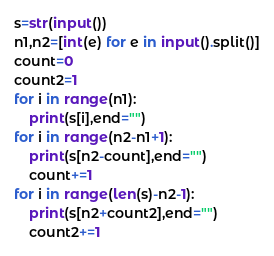<code> <loc_0><loc_0><loc_500><loc_500><_Python_>s=str(input())
n1,n2=[int(e) for e in input().split()]
count=0
count2=1
for i in range(n1):
    print(s[i],end="")
for i in range(n2-n1+1):
    print(s[n2-count],end="")
    count+=1
for i in range(len(s)-n2-1):
    print(s[n2+count2],end="")
    count2+=1
</code> 